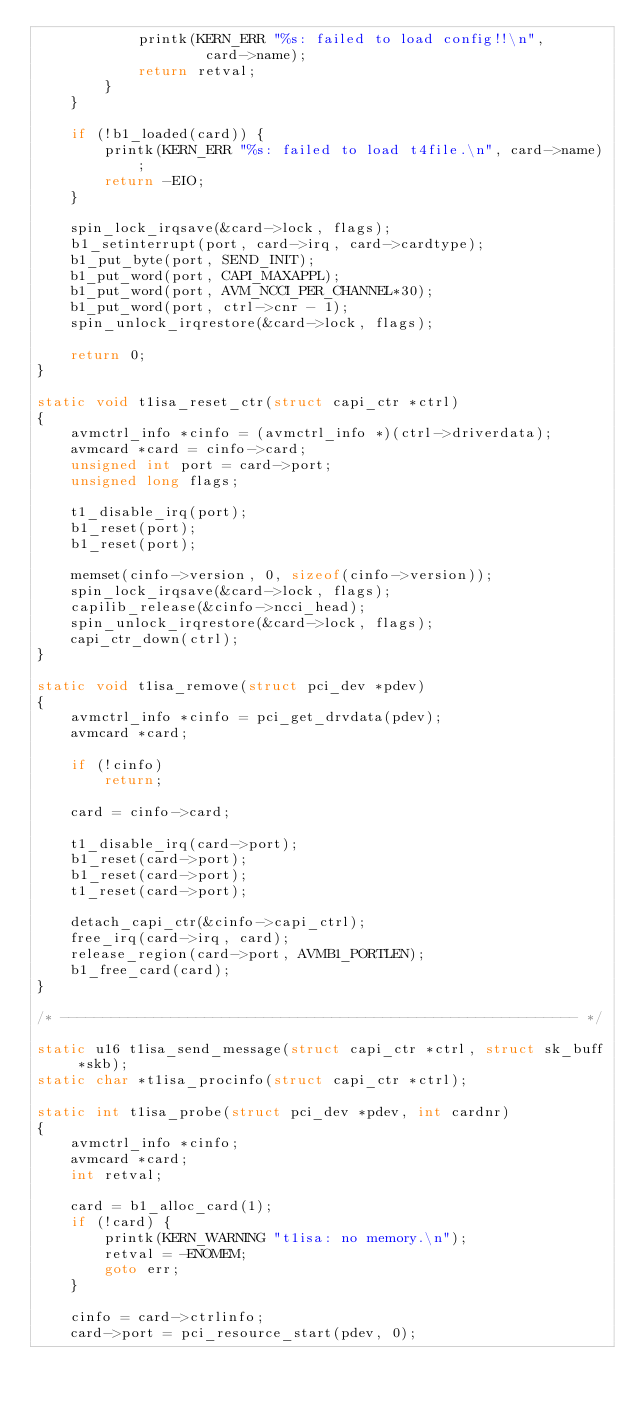<code> <loc_0><loc_0><loc_500><loc_500><_C_>			printk(KERN_ERR "%s: failed to load config!!\n",
					card->name);
			return retval;
		}
	}

	if (!b1_loaded(card)) {
		printk(KERN_ERR "%s: failed to load t4file.\n", card->name);
		return -EIO;
	}

	spin_lock_irqsave(&card->lock, flags);
	b1_setinterrupt(port, card->irq, card->cardtype);
	b1_put_byte(port, SEND_INIT);
	b1_put_word(port, CAPI_MAXAPPL);
	b1_put_word(port, AVM_NCCI_PER_CHANNEL*30);
	b1_put_word(port, ctrl->cnr - 1);
	spin_unlock_irqrestore(&card->lock, flags);

	return 0;
}

static void t1isa_reset_ctr(struct capi_ctr *ctrl)
{
	avmctrl_info *cinfo = (avmctrl_info *)(ctrl->driverdata);
	avmcard *card = cinfo->card;
	unsigned int port = card->port;
	unsigned long flags;

	t1_disable_irq(port);
	b1_reset(port);
	b1_reset(port);

	memset(cinfo->version, 0, sizeof(cinfo->version));
	spin_lock_irqsave(&card->lock, flags);
	capilib_release(&cinfo->ncci_head);
	spin_unlock_irqrestore(&card->lock, flags);
	capi_ctr_down(ctrl);
}

static void t1isa_remove(struct pci_dev *pdev)
{
	avmctrl_info *cinfo = pci_get_drvdata(pdev);
	avmcard *card;
	
	if (!cinfo)
		return;

	card = cinfo->card;

	t1_disable_irq(card->port);
	b1_reset(card->port);
	b1_reset(card->port);
	t1_reset(card->port);

	detach_capi_ctr(&cinfo->capi_ctrl);
	free_irq(card->irq, card);
	release_region(card->port, AVMB1_PORTLEN);
	b1_free_card(card);
}

/* ------------------------------------------------------------- */

static u16 t1isa_send_message(struct capi_ctr *ctrl, struct sk_buff *skb);
static char *t1isa_procinfo(struct capi_ctr *ctrl);

static int t1isa_probe(struct pci_dev *pdev, int cardnr)
{
	avmctrl_info *cinfo;
	avmcard *card;
	int retval;

	card = b1_alloc_card(1);
	if (!card) {
		printk(KERN_WARNING "t1isa: no memory.\n");
		retval = -ENOMEM;
		goto err;
	}

	cinfo = card->ctrlinfo;
	card->port = pci_resource_start(pdev, 0);</code> 